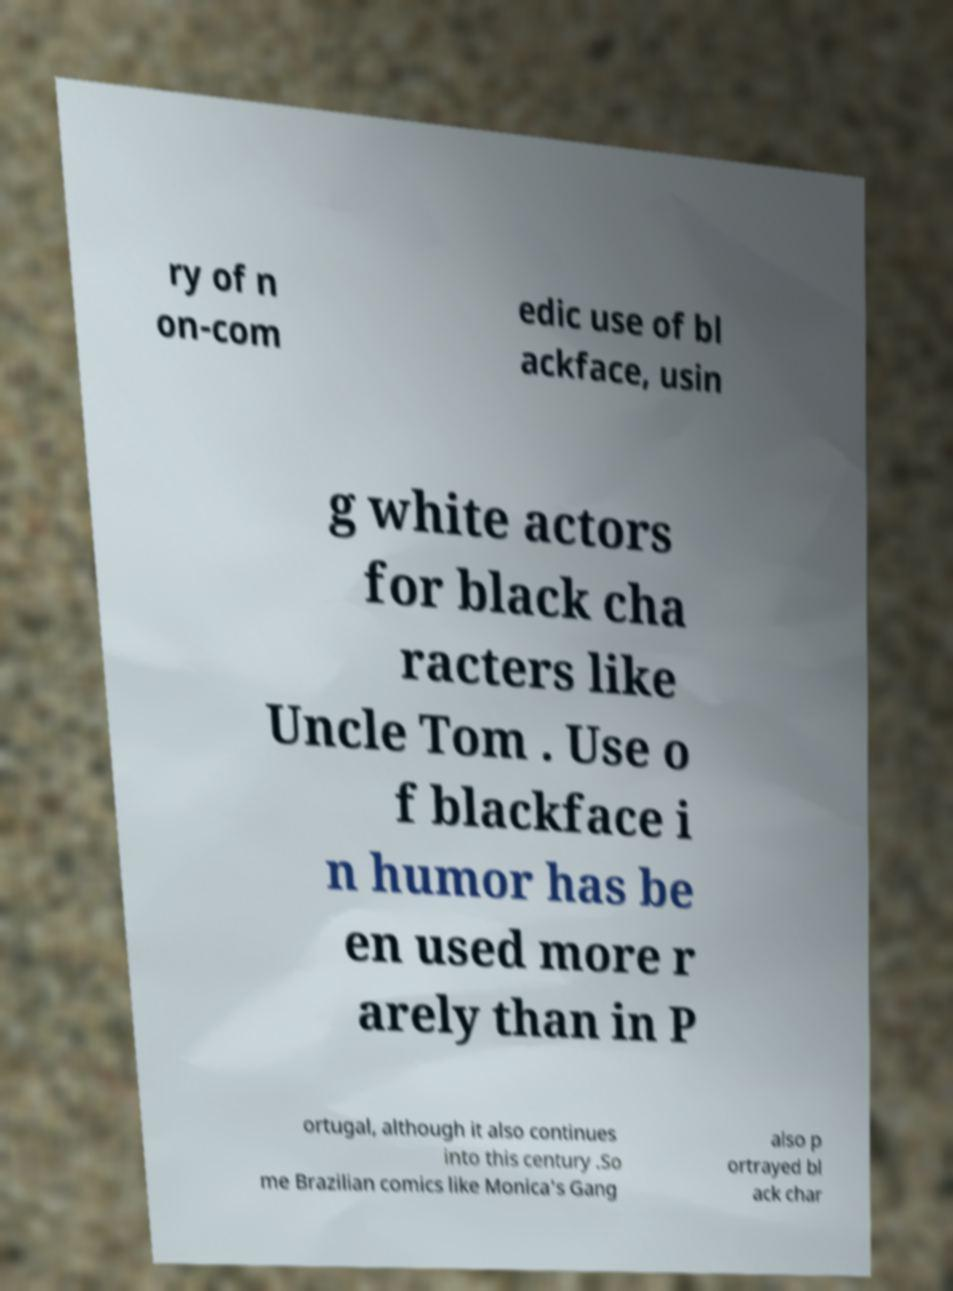Could you assist in decoding the text presented in this image and type it out clearly? ry of n on-com edic use of bl ackface, usin g white actors for black cha racters like Uncle Tom . Use o f blackface i n humor has be en used more r arely than in P ortugal, although it also continues into this century .So me Brazilian comics like Monica's Gang also p ortrayed bl ack char 